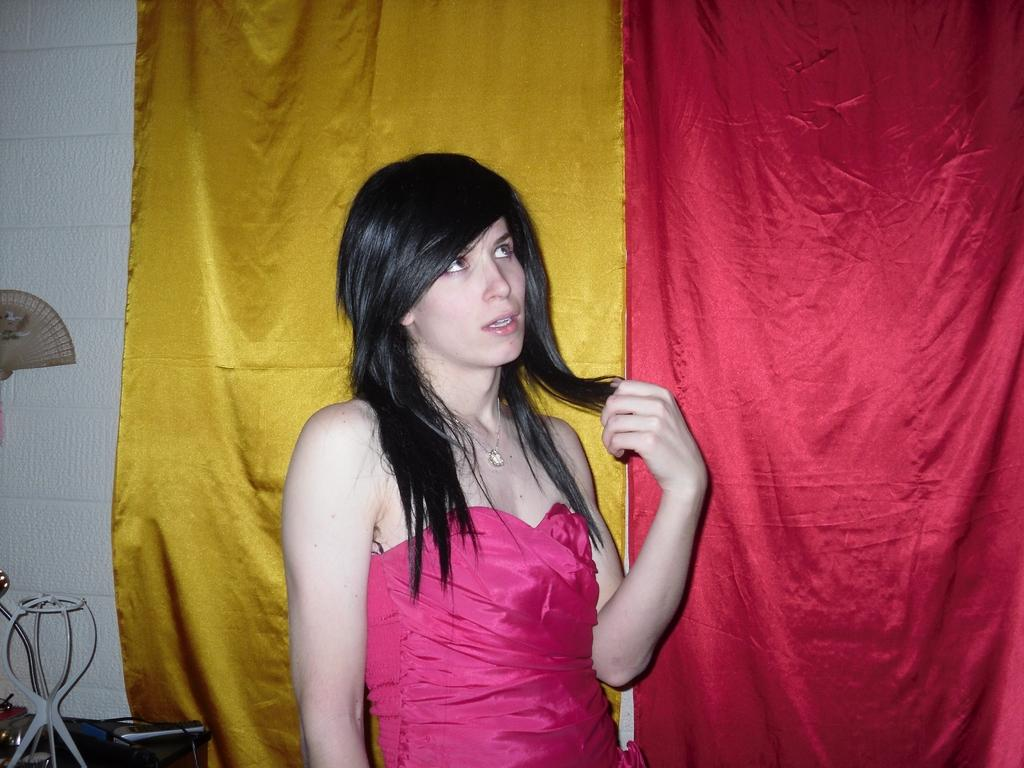Who is present in the image? There is a woman in the image. What is the woman doing in the image? The woman is standing and looking upwards. What can be seen in the background of the image? There are two different color clothes and a wall in the background. What type of waves can be seen crashing against the shore in the image? There are no waves or shore present in the image; it features a woman standing and looking upwards with a wall and two different color clothes in the background. 